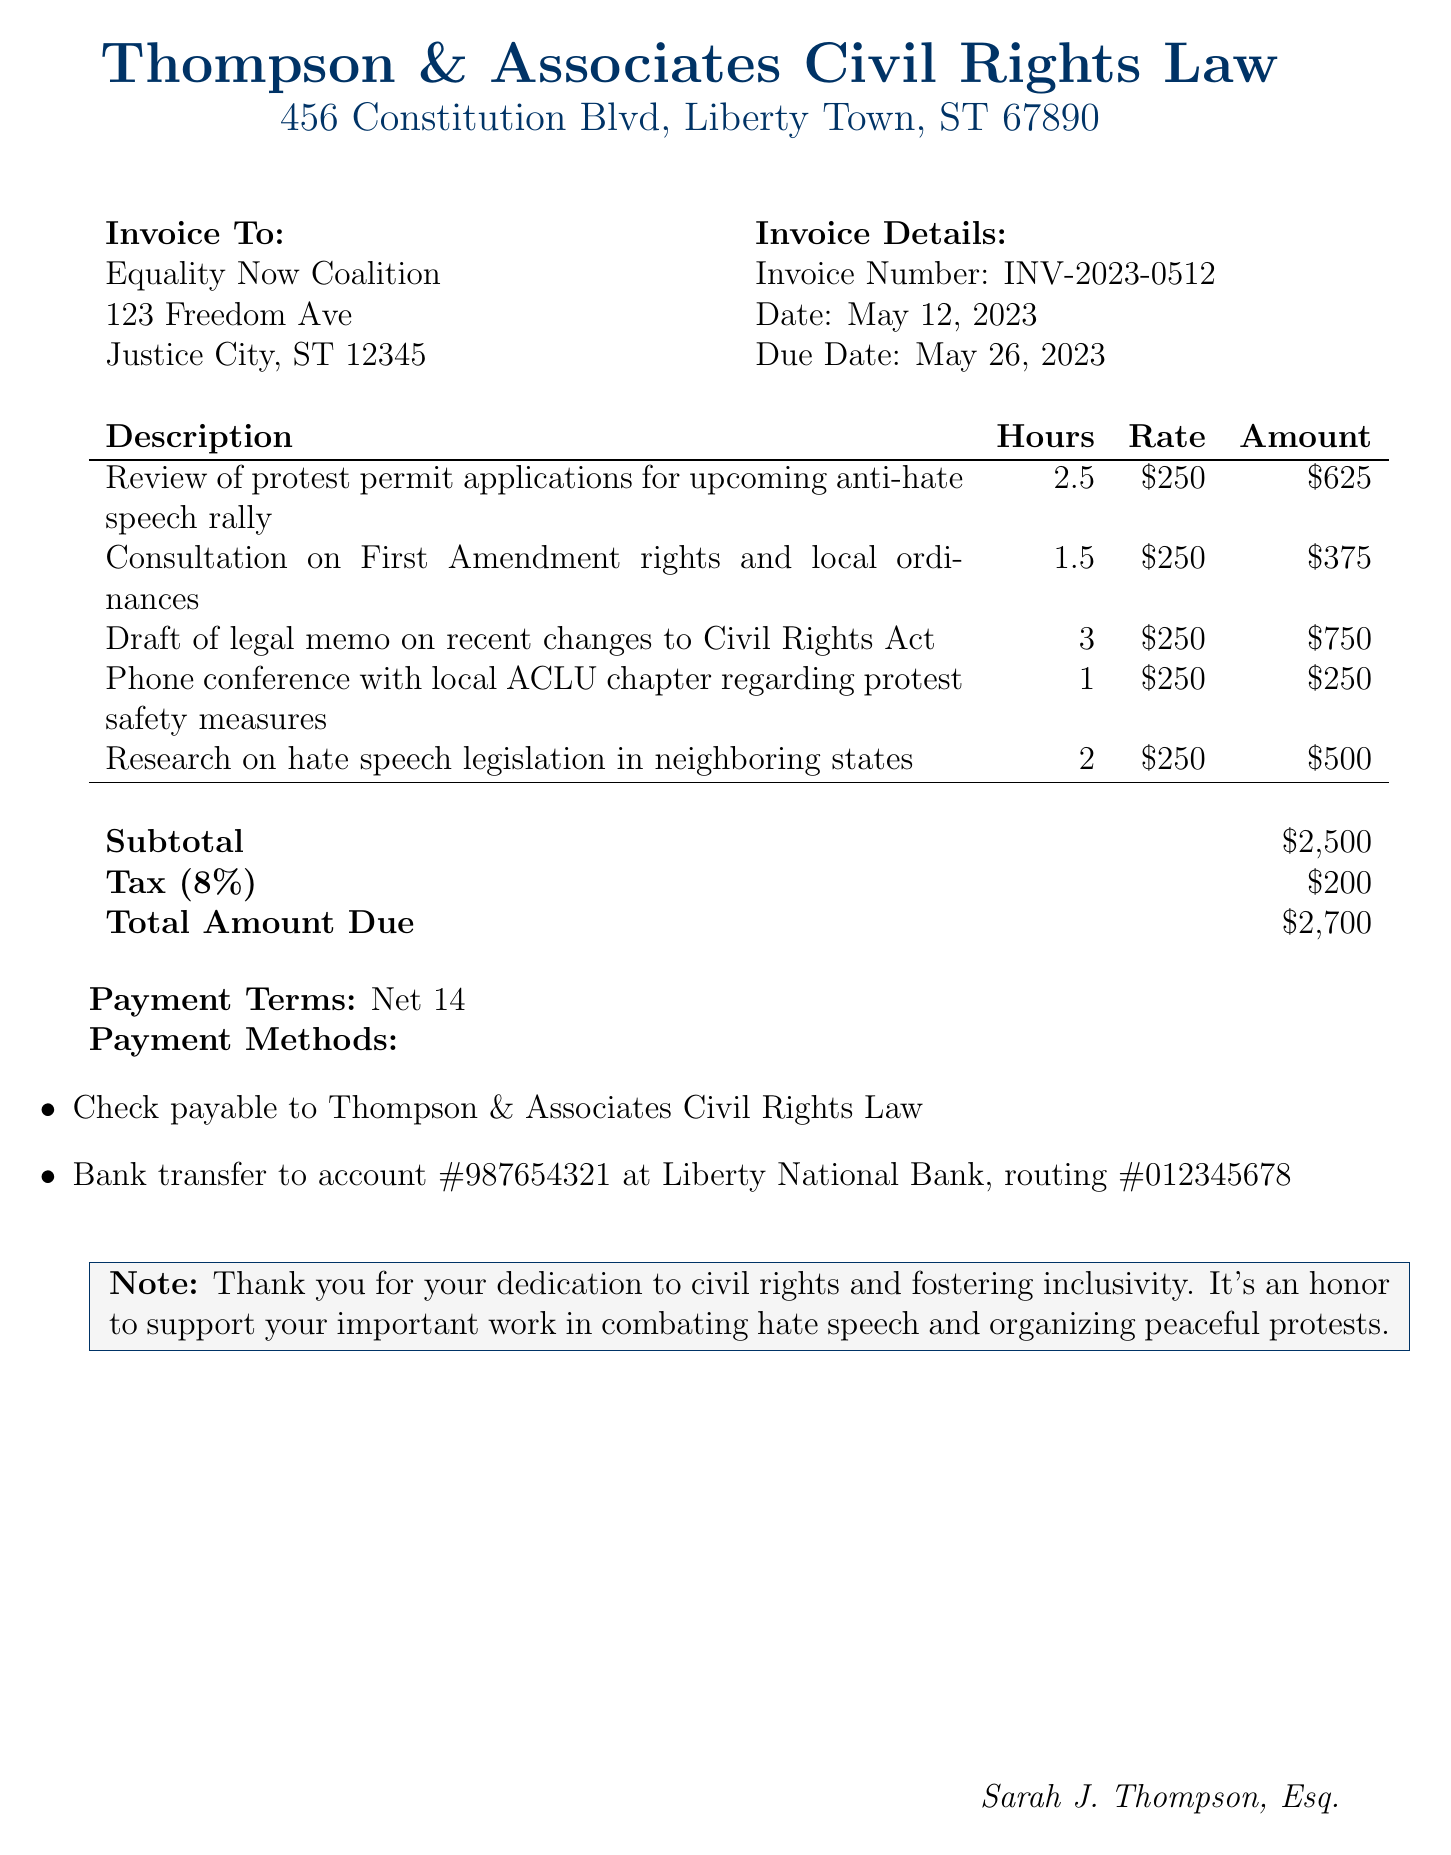What is the invoice number? The invoice number is listed in the document as a unique identifier for the invoice.
Answer: INV-2023-0512 Who is the attorney's name? The attorney's name is provided as part of the firm's contact information in the document.
Answer: Sarah J. Thompson, Esq What is the total amount due? The total amount due is calculated at the end of the invoice, taking into account the subtotal and tax.
Answer: $2,700 How many hours were billed for draft of legal memo on recent changes to Civil Rights Act? The hours billed for this specific service are listed in the services table of the document.
Answer: 3 What is the tax rate applied in this invoice? The tax rate is mentioned in the invoice section detailing the financial breakdown.
Answer: 8% What is the payment term specified in the document? The payment term indicates the timeframe in which payment should be made, as outlined in the invoice.
Answer: Net 14 What company is invoiced for the legal consultation services? The client’s name is stated at the beginning of the invoice and identifies who is being billed.
Answer: Equality Now Coalition What service involved a phone conference? The services provided include detailed descriptions of the legal tasks, one of which mentions a phone conference.
Answer: Phone conference with local ACLU chapter regarding protest safety measures 